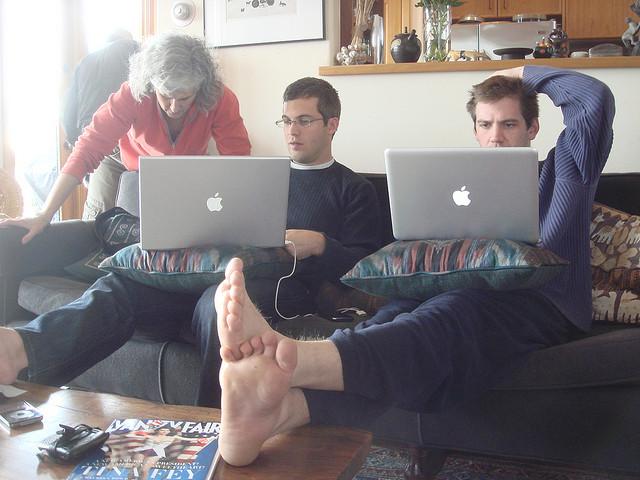What brand computers are these?
Concise answer only. Apple. What appears to be the guys moods?
Keep it brief. Serious. How many computers are there?
Short answer required. 2. 